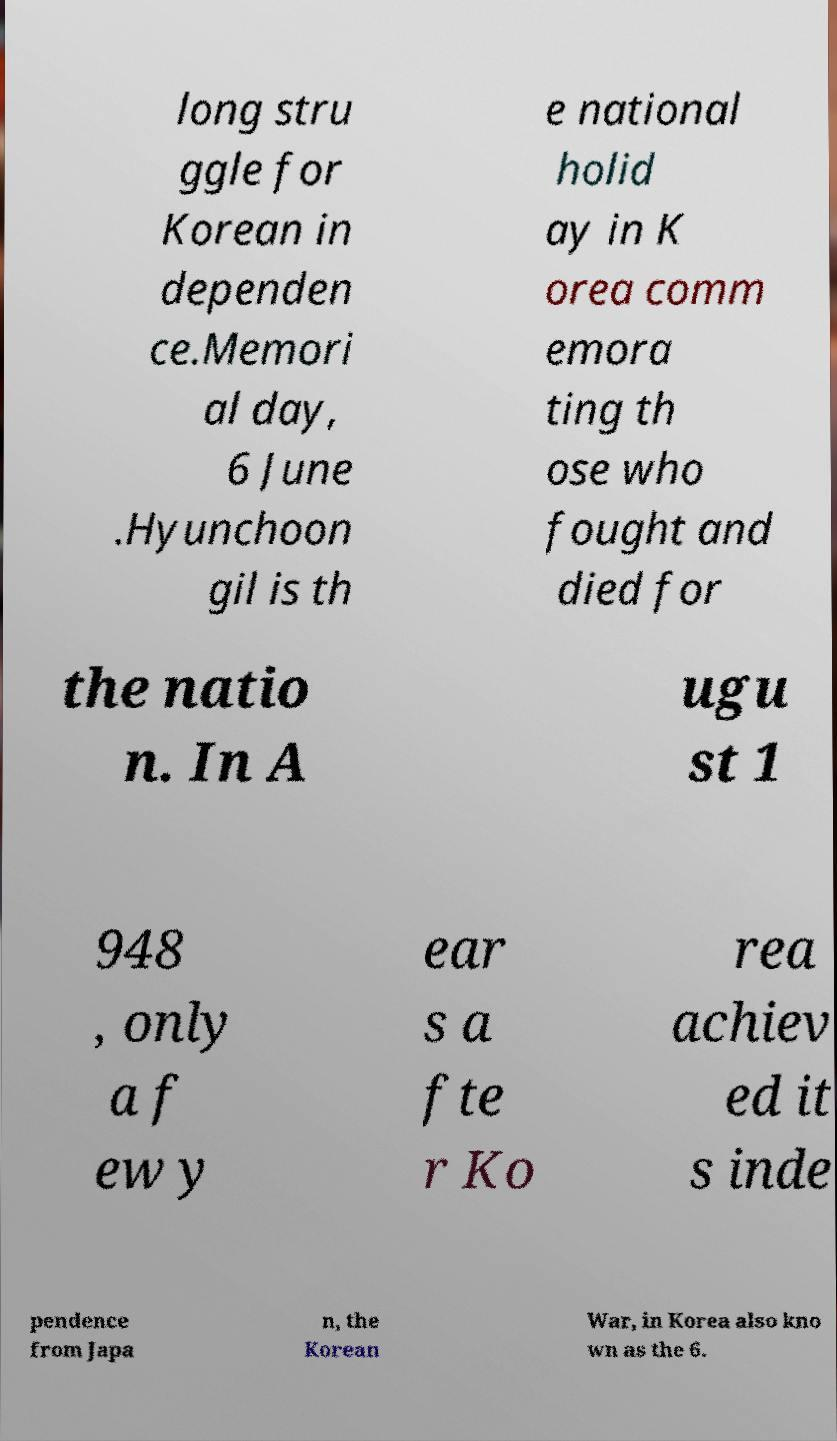For documentation purposes, I need the text within this image transcribed. Could you provide that? long stru ggle for Korean in dependen ce.Memori al day, 6 June .Hyunchoon gil is th e national holid ay in K orea comm emora ting th ose who fought and died for the natio n. In A ugu st 1 948 , only a f ew y ear s a fte r Ko rea achiev ed it s inde pendence from Japa n, the Korean War, in Korea also kno wn as the 6. 